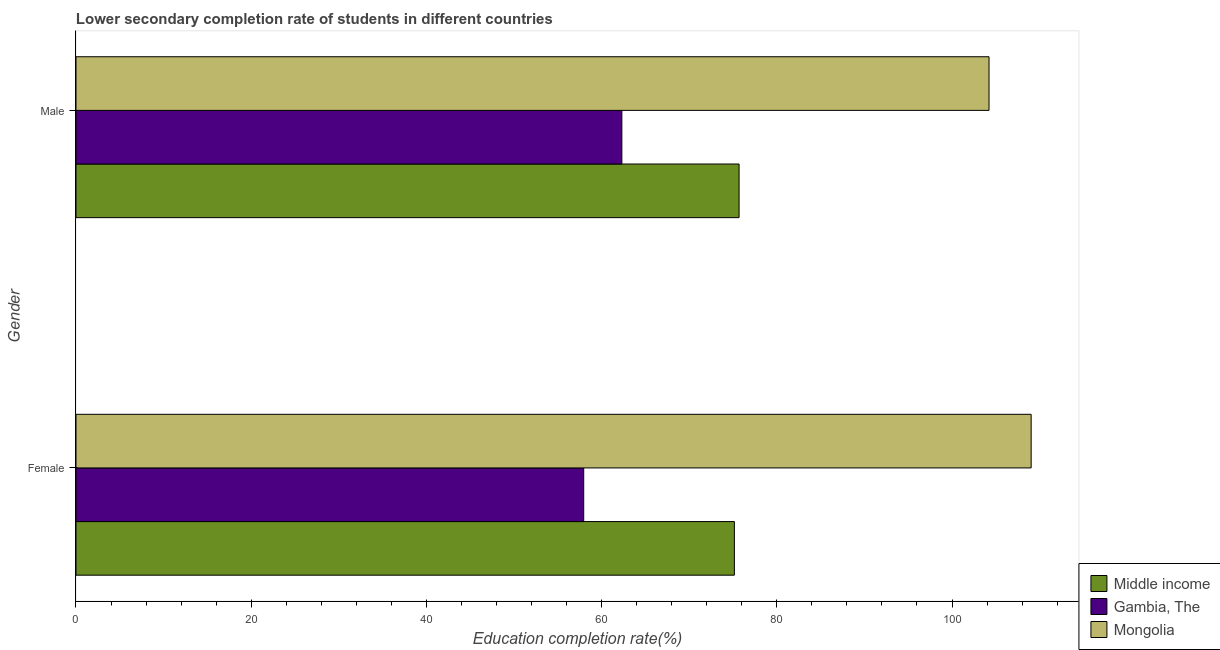How many different coloured bars are there?
Offer a terse response. 3. How many bars are there on the 2nd tick from the top?
Provide a succinct answer. 3. What is the education completion rate of female students in Mongolia?
Provide a short and direct response. 109.03. Across all countries, what is the maximum education completion rate of female students?
Your answer should be very brief. 109.03. Across all countries, what is the minimum education completion rate of male students?
Your response must be concise. 62.31. In which country was the education completion rate of male students maximum?
Offer a terse response. Mongolia. In which country was the education completion rate of male students minimum?
Your answer should be very brief. Gambia, The. What is the total education completion rate of male students in the graph?
Keep it short and to the point. 242.23. What is the difference between the education completion rate of male students in Middle income and that in Mongolia?
Your response must be concise. -28.53. What is the difference between the education completion rate of male students in Mongolia and the education completion rate of female students in Middle income?
Offer a terse response. 29.07. What is the average education completion rate of male students per country?
Make the answer very short. 80.74. What is the difference between the education completion rate of male students and education completion rate of female students in Gambia, The?
Your answer should be compact. 4.36. In how many countries, is the education completion rate of male students greater than 96 %?
Offer a very short reply. 1. What is the ratio of the education completion rate of female students in Gambia, The to that in Mongolia?
Keep it short and to the point. 0.53. Is the education completion rate of female students in Middle income less than that in Mongolia?
Offer a very short reply. Yes. In how many countries, is the education completion rate of female students greater than the average education completion rate of female students taken over all countries?
Provide a succinct answer. 1. What does the 1st bar from the top in Female represents?
Provide a succinct answer. Mongolia. What does the 3rd bar from the bottom in Male represents?
Your answer should be very brief. Mongolia. How many countries are there in the graph?
Your answer should be very brief. 3. How are the legend labels stacked?
Give a very brief answer. Vertical. What is the title of the graph?
Provide a short and direct response. Lower secondary completion rate of students in different countries. What is the label or title of the X-axis?
Offer a terse response. Education completion rate(%). What is the Education completion rate(%) in Middle income in Female?
Your answer should be very brief. 75.15. What is the Education completion rate(%) in Gambia, The in Female?
Your response must be concise. 57.96. What is the Education completion rate(%) of Mongolia in Female?
Your answer should be compact. 109.03. What is the Education completion rate(%) of Middle income in Male?
Your response must be concise. 75.69. What is the Education completion rate(%) in Gambia, The in Male?
Offer a terse response. 62.31. What is the Education completion rate(%) in Mongolia in Male?
Ensure brevity in your answer.  104.22. Across all Gender, what is the maximum Education completion rate(%) in Middle income?
Ensure brevity in your answer.  75.69. Across all Gender, what is the maximum Education completion rate(%) of Gambia, The?
Your response must be concise. 62.31. Across all Gender, what is the maximum Education completion rate(%) of Mongolia?
Provide a succinct answer. 109.03. Across all Gender, what is the minimum Education completion rate(%) of Middle income?
Your answer should be compact. 75.15. Across all Gender, what is the minimum Education completion rate(%) of Gambia, The?
Provide a succinct answer. 57.96. Across all Gender, what is the minimum Education completion rate(%) in Mongolia?
Keep it short and to the point. 104.22. What is the total Education completion rate(%) in Middle income in the graph?
Make the answer very short. 150.85. What is the total Education completion rate(%) in Gambia, The in the graph?
Provide a succinct answer. 120.27. What is the total Education completion rate(%) of Mongolia in the graph?
Offer a very short reply. 213.26. What is the difference between the Education completion rate(%) in Middle income in Female and that in Male?
Your answer should be compact. -0.54. What is the difference between the Education completion rate(%) of Gambia, The in Female and that in Male?
Your answer should be very brief. -4.36. What is the difference between the Education completion rate(%) in Mongolia in Female and that in Male?
Give a very brief answer. 4.81. What is the difference between the Education completion rate(%) in Middle income in Female and the Education completion rate(%) in Gambia, The in Male?
Ensure brevity in your answer.  12.84. What is the difference between the Education completion rate(%) in Middle income in Female and the Education completion rate(%) in Mongolia in Male?
Provide a short and direct response. -29.07. What is the difference between the Education completion rate(%) in Gambia, The in Female and the Education completion rate(%) in Mongolia in Male?
Ensure brevity in your answer.  -46.27. What is the average Education completion rate(%) in Middle income per Gender?
Your answer should be very brief. 75.42. What is the average Education completion rate(%) in Gambia, The per Gender?
Your answer should be very brief. 60.13. What is the average Education completion rate(%) in Mongolia per Gender?
Give a very brief answer. 106.63. What is the difference between the Education completion rate(%) in Middle income and Education completion rate(%) in Gambia, The in Female?
Provide a short and direct response. 17.2. What is the difference between the Education completion rate(%) in Middle income and Education completion rate(%) in Mongolia in Female?
Your answer should be compact. -33.88. What is the difference between the Education completion rate(%) of Gambia, The and Education completion rate(%) of Mongolia in Female?
Your response must be concise. -51.08. What is the difference between the Education completion rate(%) in Middle income and Education completion rate(%) in Gambia, The in Male?
Your answer should be very brief. 13.38. What is the difference between the Education completion rate(%) of Middle income and Education completion rate(%) of Mongolia in Male?
Give a very brief answer. -28.53. What is the difference between the Education completion rate(%) of Gambia, The and Education completion rate(%) of Mongolia in Male?
Make the answer very short. -41.91. What is the ratio of the Education completion rate(%) in Gambia, The in Female to that in Male?
Your answer should be very brief. 0.93. What is the ratio of the Education completion rate(%) of Mongolia in Female to that in Male?
Your answer should be compact. 1.05. What is the difference between the highest and the second highest Education completion rate(%) in Middle income?
Provide a succinct answer. 0.54. What is the difference between the highest and the second highest Education completion rate(%) in Gambia, The?
Make the answer very short. 4.36. What is the difference between the highest and the second highest Education completion rate(%) of Mongolia?
Your answer should be compact. 4.81. What is the difference between the highest and the lowest Education completion rate(%) in Middle income?
Give a very brief answer. 0.54. What is the difference between the highest and the lowest Education completion rate(%) in Gambia, The?
Your answer should be very brief. 4.36. What is the difference between the highest and the lowest Education completion rate(%) in Mongolia?
Offer a terse response. 4.81. 